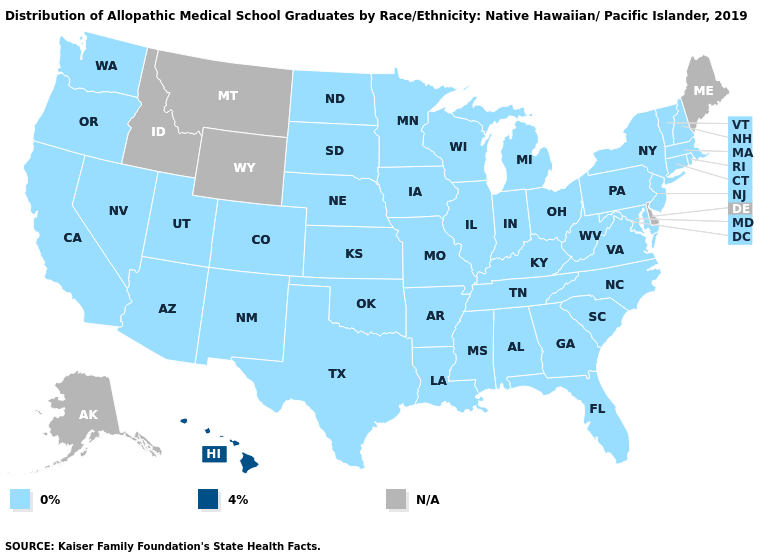Name the states that have a value in the range 0%?
Give a very brief answer. Alabama, Arizona, Arkansas, California, Colorado, Connecticut, Florida, Georgia, Illinois, Indiana, Iowa, Kansas, Kentucky, Louisiana, Maryland, Massachusetts, Michigan, Minnesota, Mississippi, Missouri, Nebraska, Nevada, New Hampshire, New Jersey, New Mexico, New York, North Carolina, North Dakota, Ohio, Oklahoma, Oregon, Pennsylvania, Rhode Island, South Carolina, South Dakota, Tennessee, Texas, Utah, Vermont, Virginia, Washington, West Virginia, Wisconsin. What is the highest value in states that border Alabama?
Keep it brief. 0%. Name the states that have a value in the range N/A?
Give a very brief answer. Alaska, Delaware, Idaho, Maine, Montana, Wyoming. Which states hav the highest value in the West?
Answer briefly. Hawaii. Name the states that have a value in the range 4%?
Short answer required. Hawaii. Does the first symbol in the legend represent the smallest category?
Give a very brief answer. Yes. Which states hav the highest value in the West?
Keep it brief. Hawaii. Name the states that have a value in the range 0%?
Write a very short answer. Alabama, Arizona, Arkansas, California, Colorado, Connecticut, Florida, Georgia, Illinois, Indiana, Iowa, Kansas, Kentucky, Louisiana, Maryland, Massachusetts, Michigan, Minnesota, Mississippi, Missouri, Nebraska, Nevada, New Hampshire, New Jersey, New Mexico, New York, North Carolina, North Dakota, Ohio, Oklahoma, Oregon, Pennsylvania, Rhode Island, South Carolina, South Dakota, Tennessee, Texas, Utah, Vermont, Virginia, Washington, West Virginia, Wisconsin. Which states have the lowest value in the USA?
Keep it brief. Alabama, Arizona, Arkansas, California, Colorado, Connecticut, Florida, Georgia, Illinois, Indiana, Iowa, Kansas, Kentucky, Louisiana, Maryland, Massachusetts, Michigan, Minnesota, Mississippi, Missouri, Nebraska, Nevada, New Hampshire, New Jersey, New Mexico, New York, North Carolina, North Dakota, Ohio, Oklahoma, Oregon, Pennsylvania, Rhode Island, South Carolina, South Dakota, Tennessee, Texas, Utah, Vermont, Virginia, Washington, West Virginia, Wisconsin. Which states have the lowest value in the USA?
Short answer required. Alabama, Arizona, Arkansas, California, Colorado, Connecticut, Florida, Georgia, Illinois, Indiana, Iowa, Kansas, Kentucky, Louisiana, Maryland, Massachusetts, Michigan, Minnesota, Mississippi, Missouri, Nebraska, Nevada, New Hampshire, New Jersey, New Mexico, New York, North Carolina, North Dakota, Ohio, Oklahoma, Oregon, Pennsylvania, Rhode Island, South Carolina, South Dakota, Tennessee, Texas, Utah, Vermont, Virginia, Washington, West Virginia, Wisconsin. What is the highest value in the USA?
Quick response, please. 4%. What is the value of Nebraska?
Quick response, please. 0%. 